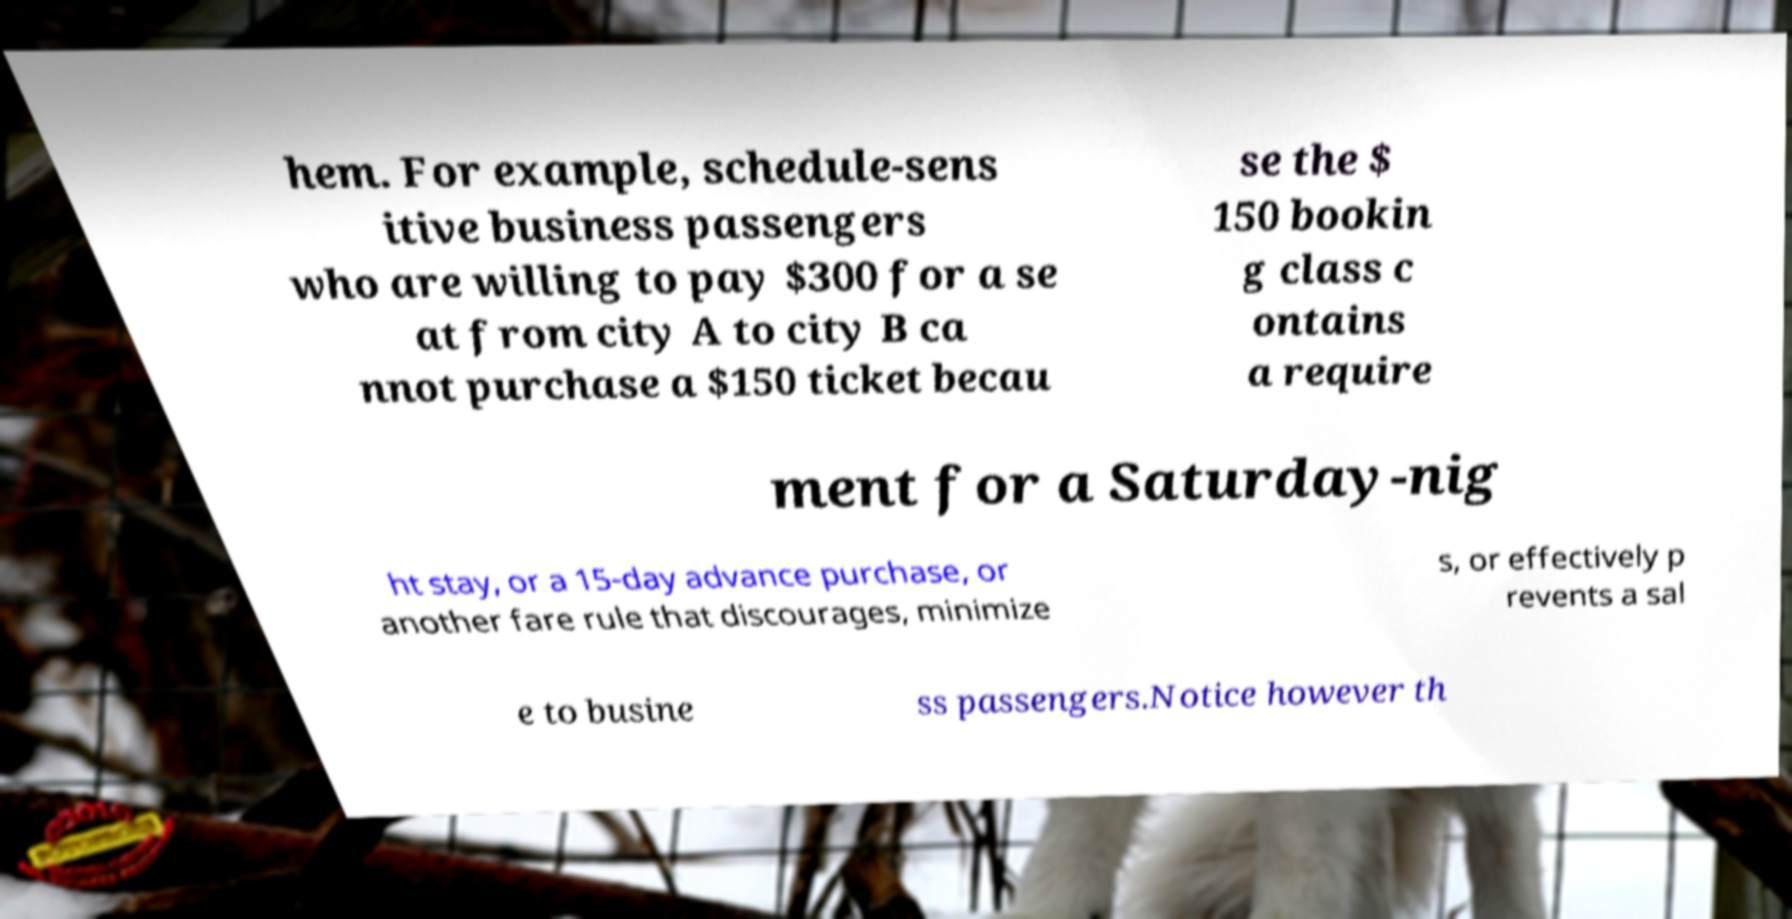Please identify and transcribe the text found in this image. hem. For example, schedule-sens itive business passengers who are willing to pay $300 for a se at from city A to city B ca nnot purchase a $150 ticket becau se the $ 150 bookin g class c ontains a require ment for a Saturday-nig ht stay, or a 15-day advance purchase, or another fare rule that discourages, minimize s, or effectively p revents a sal e to busine ss passengers.Notice however th 